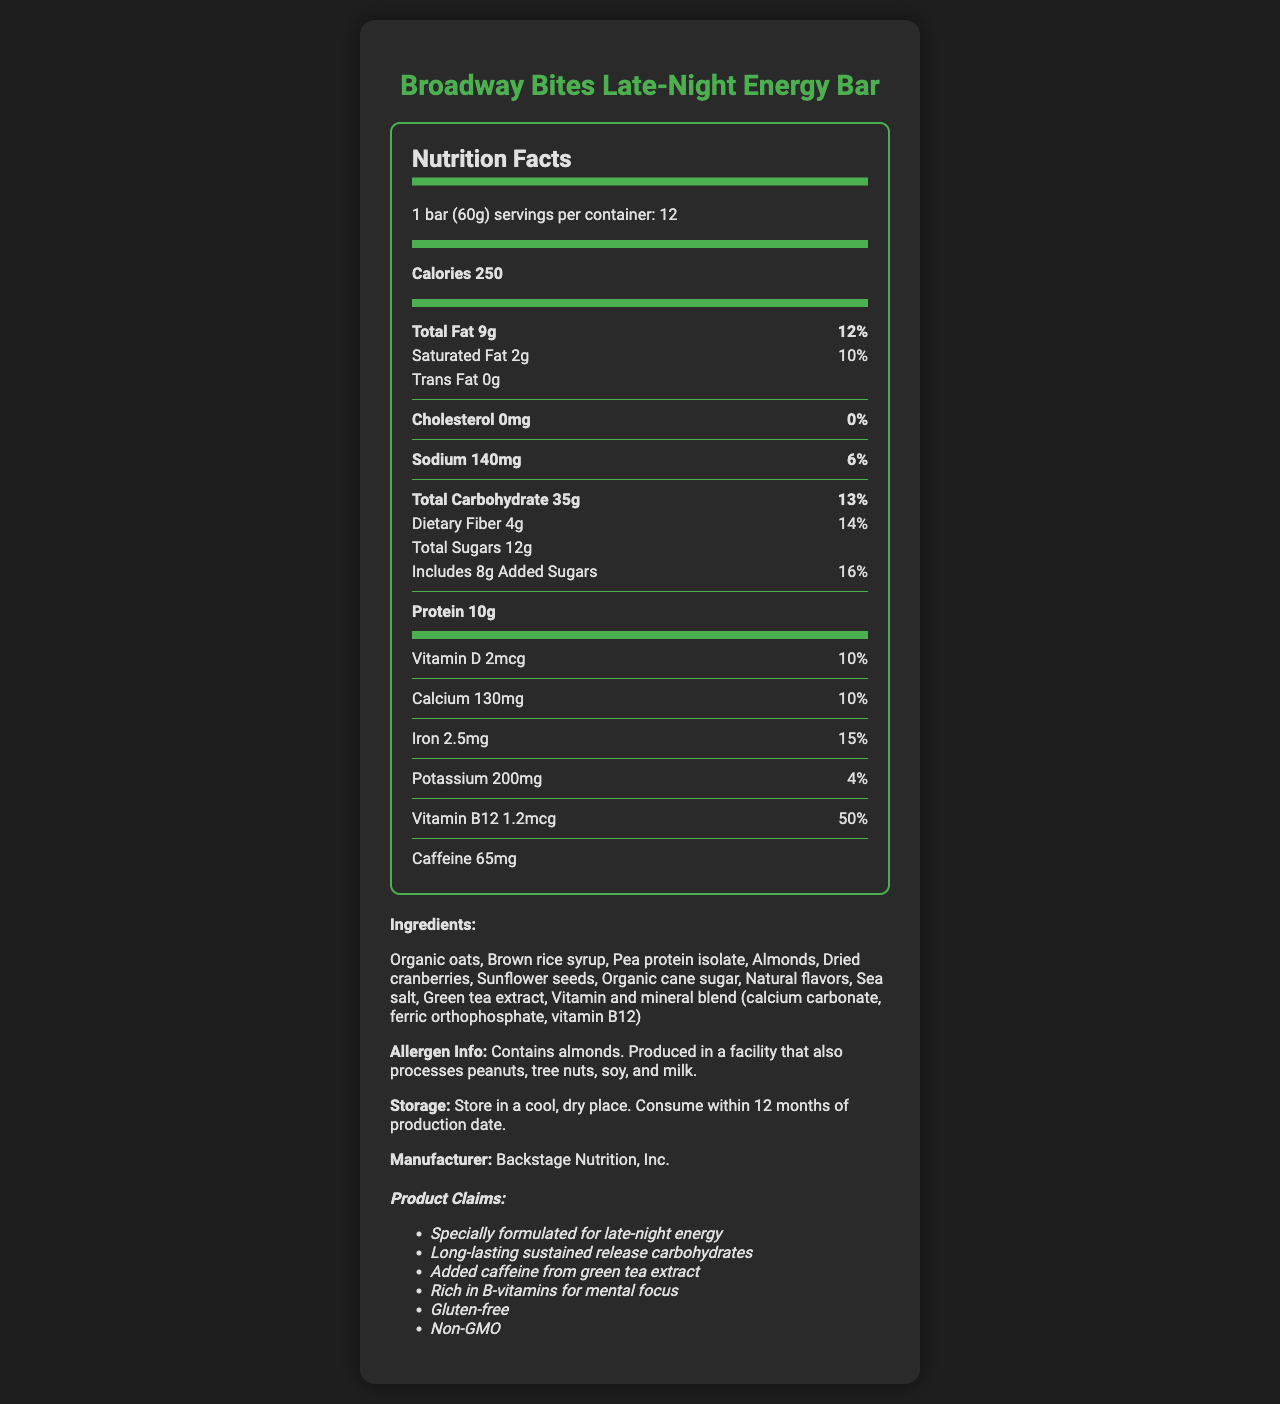what is the serving size? The serving size is explicitly stated as "1 bar (60g)" in the document.
Answer: 1 bar (60g) how many servings are in each container? The document mentions that there are 12 servings per container.
Answer: 12 how many calories are in one serving of the energy bar? The document lists the calories per serving as 250.
Answer: 250 what is the total fat content per serving? The total fat content per serving is specified as 9g on the document.
Answer: 9g what is the daily value percentage of saturated fat in one serving? The daily value percentage for saturated fat per serving is provided as 10%.
Answer: 10% how much added sugar is in one bar? The document states that each bar contains 8g of added sugar.
Answer: 8g does the energy bar contain trans fat? The trans fat amount is listed as 0g, indicating that there is no trans fat in the energy bar.
Answer: No how much protein does one serving provide? The protein content per serving is listed as 10g.
Answer: 10g how much caffeine is in one energy bar? The document indicates that each bar contains 65mg of caffeine.
Answer: 65mg which organization manufactures the energy bar? The manufacturer is stated as Backstage Nutrition, Inc.
Answer: Backstage Nutrition, Inc. what is the daily value percentage of vitamin B12 in one bar? The daily value percentage for vitamin B12 per bar is listed as 50%.
Answer: 50% what are the storage instructions for the energy bar? The storage instructions are clearly mentioned as "Store in a cool, dry place. Consume within 12 months of production date."
Answer: Store in a cool, dry place. Consume within 12 months of production date. which of the following is a key ingredient in the energy bar? A. Wheat B. Organic oats C. Honey D. Peanut butter The list of ingredients includes "Organic oats" as one of the main ingredients.
Answer: B. Organic oats how much sodium is in each serving? A. 50mg B. 140mg C. 200mg D. 300mg The document lists the sodium content per serving as 140mg.
Answer: B. 140mg what nutrient has a daily value of 15% in one bar? A. Vitamin D B. Iron C. Calcium D. Potassium The iron content per serving has a daily value percentage of 15%.
Answer: B. Iron is the energy bar gluten-free? One of the product claims explicitly states that the bar is gluten-free.
Answer: Yes summarize the main idea of the document. The detailed description from the document covers nutrition facts, benefits, storage, allergen information, and manufacturing details.
Answer: The document provides detailed nutrition facts for the "Broadway Bites Late-Night Energy Bar," including caloric information, fat content, vitamins, minerals, and ingredients. It emphasizes the bar's benefits for late-night energy with added caffeine and B-vitamins, and notes that it is gluten-free and non-GMO. The storage instructions, allergen info, and manufacturer details are also provided. what is the production date of the energy bar? The document does not provide the production date of the energy bar, only the storage instructions which mention to consume within 12 months of production date.
Answer: Not enough information 